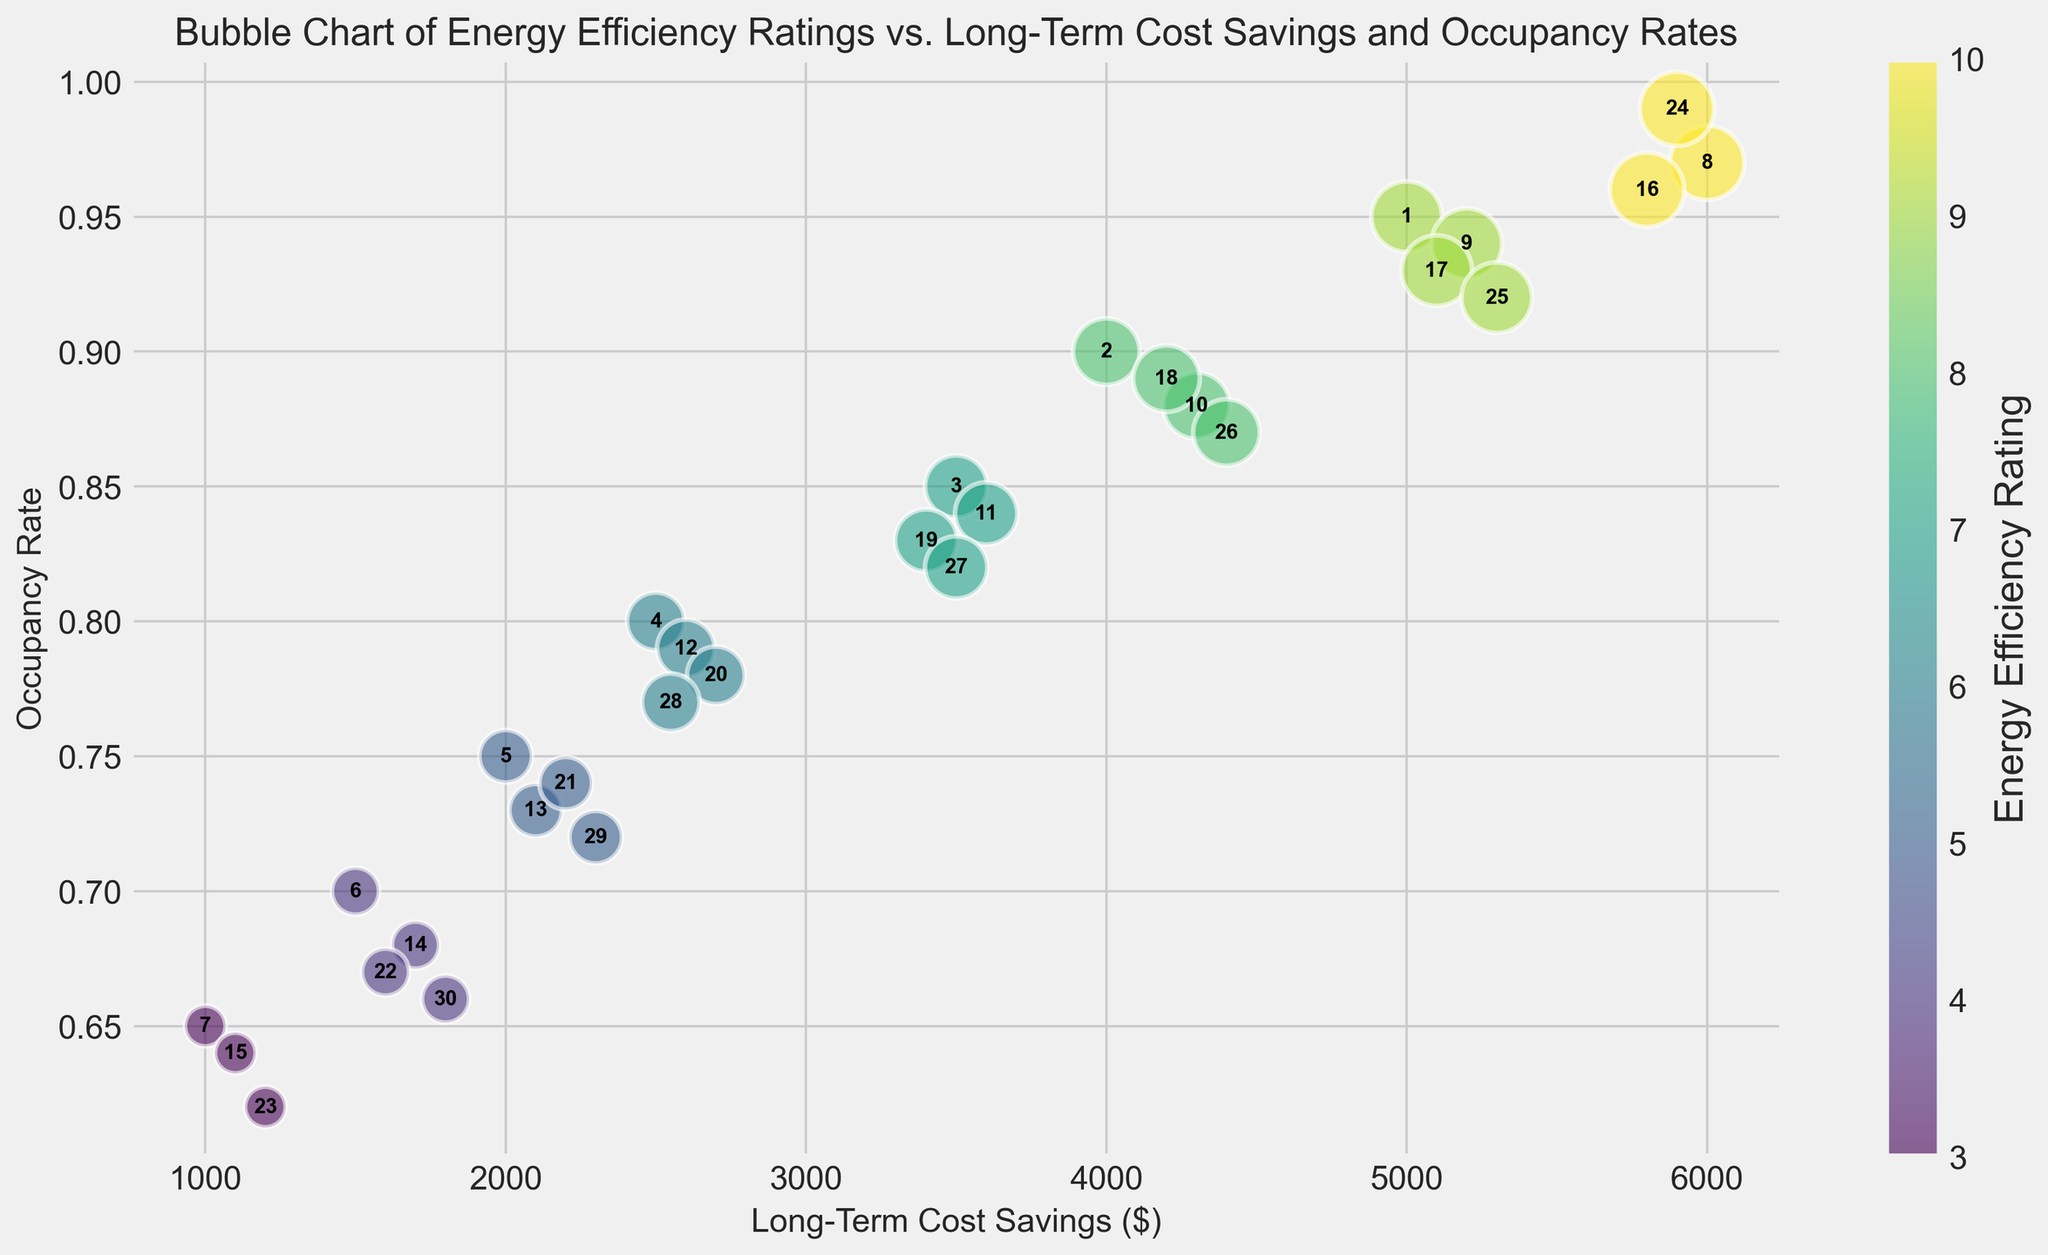Which property has the highest long-term cost savings? To find the property with the highest long-term cost savings, look at the x-axis values and identify the highest value. The highest value of long-term cost savings is 6000. The property_id with this value is 8.
Answer: 8 What is the average occupancy rate for properties with an energy efficiency rating of 'A+'? First, identify all properties with an 'A+' rating, which are properties 8, 16, and 24. Then, find their occupancy rates (0.97, 0.96, and 0.99). Calculate the average: (0.97 + 0.96 + 0.99) / 3 = 2.92 / 3 = 0.9733.
Answer: 0.9733 Which rating category has the largest average bubble size in the chart? The bubble size is determined by the energy efficiency rating, with larger sizes indicating better ratings. 'A+' has the largest bubble size (10), followed by 'A' (9), 'B+' (8), and so on. Thus, the largest average bubble size is in the 'A+' category.
Answer: A+ How does the occupancy rate of property 4 compare to that of property 20? Identify the properties by their numbers and compare their occupancy rates. Property 4 has an occupancy rate of 0.80, and property 20 has 0.78. Therefore, property 4 has a higher occupancy rate.
Answer: Property 4 has a higher occupancy rate Is there a correlation between long-term cost savings and energy efficiency rating? Check the color shading, which represents energy efficiency rating, against the x-axis (long-term cost savings). Generally, higher savings (to the right) correlate with better ratings (darker colors). This suggests a positive correlation: better ratings (darker shades) are associated with higher long-term cost savings.
Answer: Yes, positive correlation Which property has the lowest occupancy rate among those with a 'D' rating? Identify all properties with a 'D' rating: properties 7, 15, and 23. Their occupancy rates are 0.65, 0.64, and 0.62, respectively. The lowest occupancy rate is 0.62, which corresponds to property 23.
Answer: 23 What is the total long-term cost savings for properties with 'B' ratings? Find all properties with a 'B' rating: properties 3, 11, 19, and 27. Their long-term cost savings are 3500, 3600, 3400, and 3500, respectively. Sum these values: 3500 + 3600 + 3400 + 3500 = 14000.
Answer: 14000 Compare the occupancy rates of properties with 'C' and 'D+' ratings. Which group has a higher average occupancy rate? Identify properties with 'C' ratings: 5, 13, 21, and 29. Their occupancy rates are 0.75, 0.73, 0.74, and 0.72. Average = (0.75 + 0.73 + 0.74 + 0.72) / 4 = 2.94 / 4 = 0.735. For 'D+' ratings: 6, 14, 22, and 30. Their rates are 0.70, 0.68, 0.67, and 0.66. Average = (0.70 + 0.68 + 0.67 + 0.66) / 4 = 2.71 / 4 = 0.6775. Thus, 'C' has a higher average occupancy rate.
Answer: 'C' rating has a higher average occupancy rate What is the visual trend between energy efficiency ratings and long-term cost savings? Observing the color gradient and their positions on the x-axis, properties with higher energy efficiency ratings (darker colors) generally show higher long-term cost savings (towards the right). This indicates properties with better energy efficiency ratings tend to have higher long-term cost savings visually.
Answer: Higher ratings show higher savings Which property ID stands out as an outlier in terms of both high long-term cost savings and occupancy rate? Look for properties that are distinctly separated from the majority in terms of both x (long-term cost savings) and y (occupancy rate). Property 24 stands out with both high values of long-term cost savings (5900) and occupancy rate (0.99).
Answer: 24 